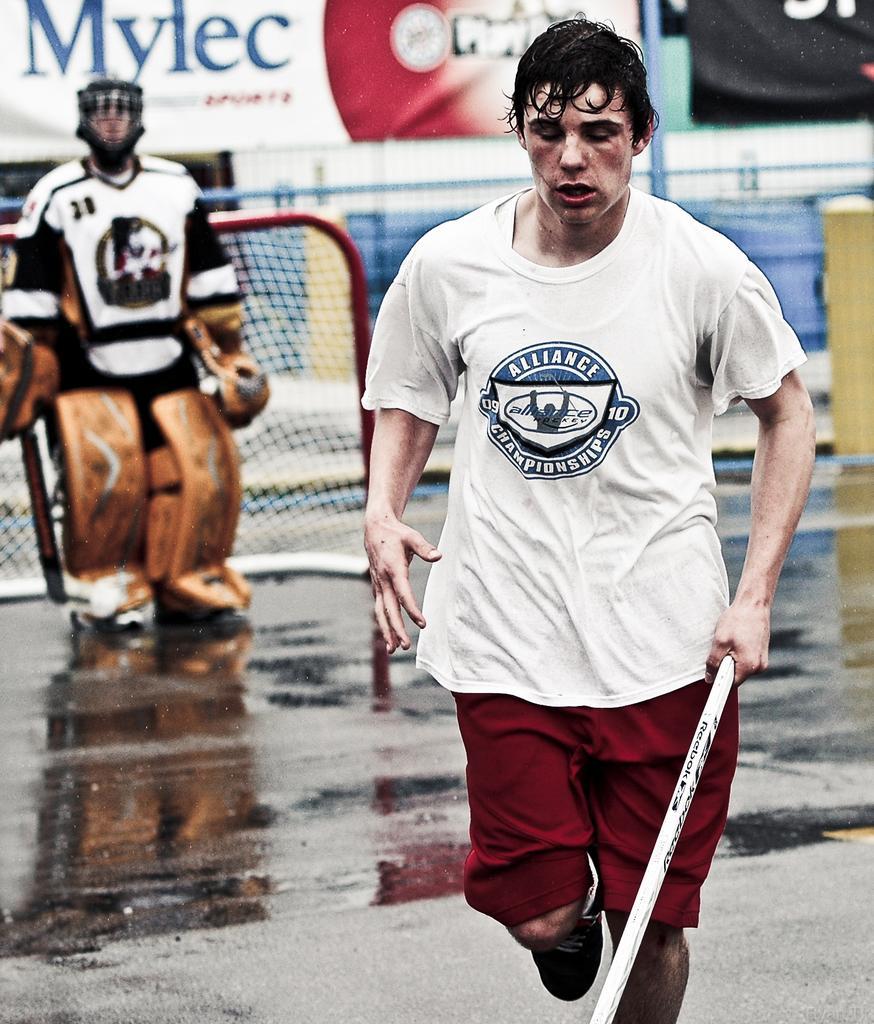In one or two sentences, can you explain what this image depicts? In this picture there is a man who is wearing white t-shirt, short and shoe. He is holding a stick. On the left we can see a goalkeeper who is wearing helmet, jacket, gloves, pads and shoe. He is standing near to the net. On the background we can see fencing and banners. On the bottom left we can see water. 